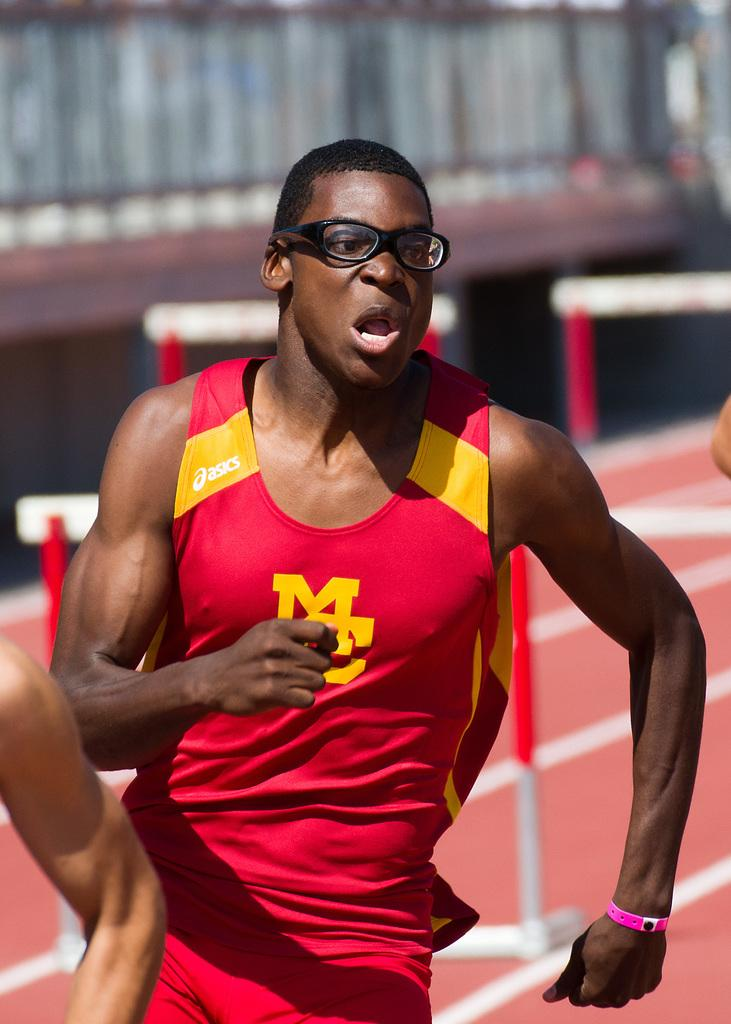<image>
Give a short and clear explanation of the subsequent image. The athlete wears a red and yellow asics shirt. 